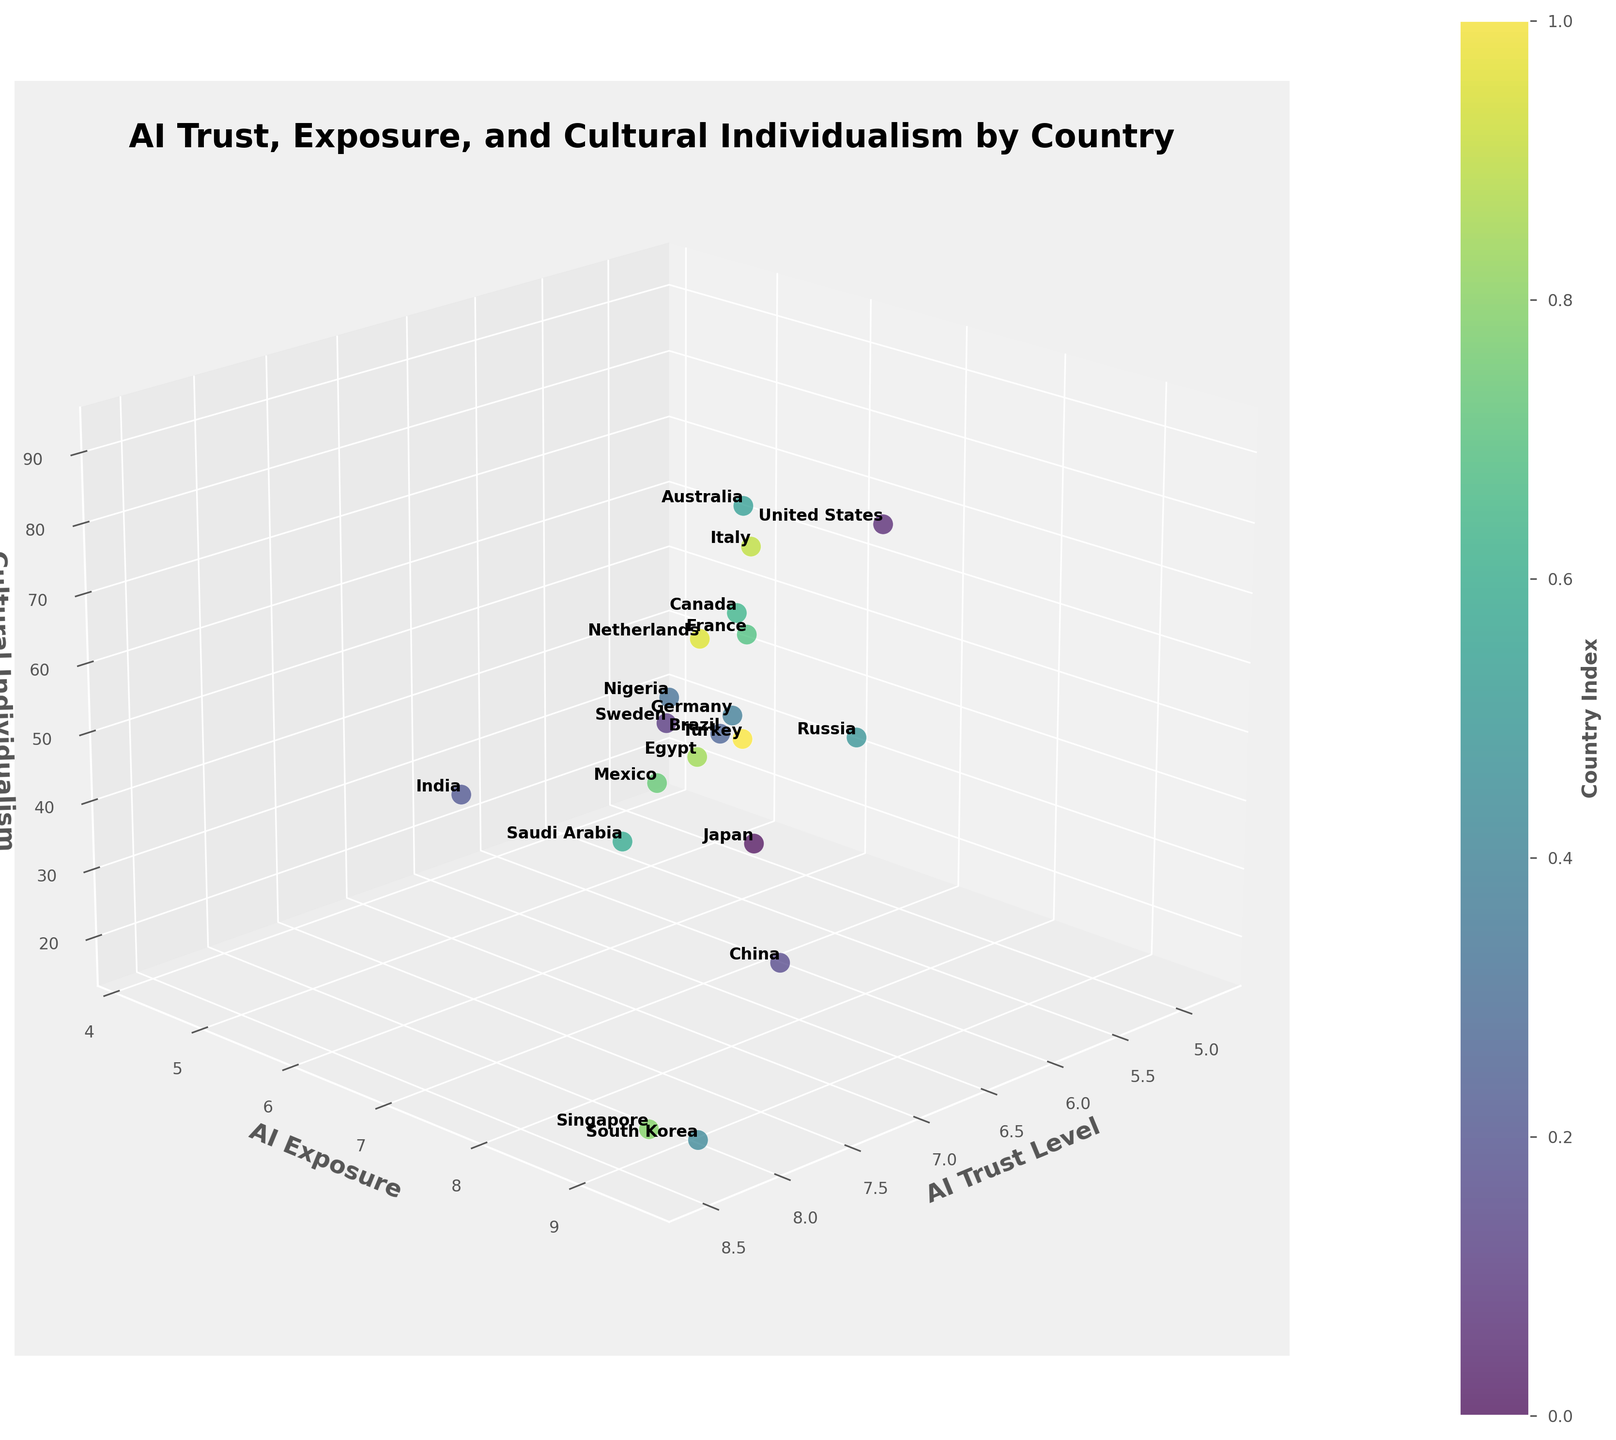How many countries are represented in the plot? By looking at the scatter plot, one can count the number of distinct data points that represent countries. Given the input data of 20 countries, the plot should show the same number of data points.
Answer: 20 Which country has the highest level of AI trust? The highest AI trust level can be identified by looking at the scatter plot for the data point that coordinates with the highest value on the AI Trust Level axis. Singapore, with an AI trust level of 8.5, represents the highest level.
Answer: Singapore What is the relationship between AI trust level and AI exposure for South Korea? By locating the data point for South Korea on the 3D scatter plot, we can observe the coordinates along the AI Trust Level and AI Exposure axes. South Korea has high values for both AI trust (8.3) and AI exposure (9.5).
Answer: Both are high What is the average AI trust level for Canada, Germany, and France? First, locate the points of Canada (7.4), Germany (7.5), and France (6.9) on the AI Trust Level axis. Sum these values (7.4 + 7.5 + 6.9 = 21.8) and then divide by the number of countries (3) to find the average.
Answer: 7.27 Which country has a lower AI exposure: Nigeria or Saudi Arabia? Compare the coordinates along the AI Exposure axis for Nigeria (4.2) and Saudi Arabia (5.7). Nigeria has a lower level of AI exposure.
Answer: Nigeria How does the cultural individualism of Japan compare to that of Mexico? Compare the values of the Cultural Individualism axis for Japan (46) and Mexico (30). Japan has a higher individualism score.
Answer: Japan What is the central theme of the plot based on the title? By reading the title of the 3D scatter plot, which is prominently displayed, one can infer that it examines the correlation between AI trust levels, exposure to AI technologies, and cultural values across global populations.
Answer: Correlation between AI trust, exposure, and cultural values Identify the country with the highest cultural individualism score and its corresponding AI trust level and exposure. Locate the point with the highest value on the Cultural Individualism axis, which is the United States with a score of 91. Its corresponding AI Trust Level and AI Exposure are 6.8 and 9.2, respectively.
Answer: United States: 6.8, 9.2 In which quadrant of the plot would you find countries with high AI trust but low cultural individualism? To identify this quadrant, look for data points with high values on the AI Trust Level axis but low values on the Cultural Individualism axis. Countries like South Korea and Singapore fall into this category.
Answer: High AI trust, low cultural individualism Does Sweden have a higher AI exposure than Italy, and if so, by how much? Compare the AI Exposure coordinates for Sweden (8.9) and Italy (7.2). Calculate the difference (8.9 - 7.2 = 1.7) to find how much higher Sweden's AI exposure is.
Answer: Yes, by 1.7 